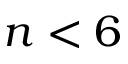<formula> <loc_0><loc_0><loc_500><loc_500>n < 6</formula> 